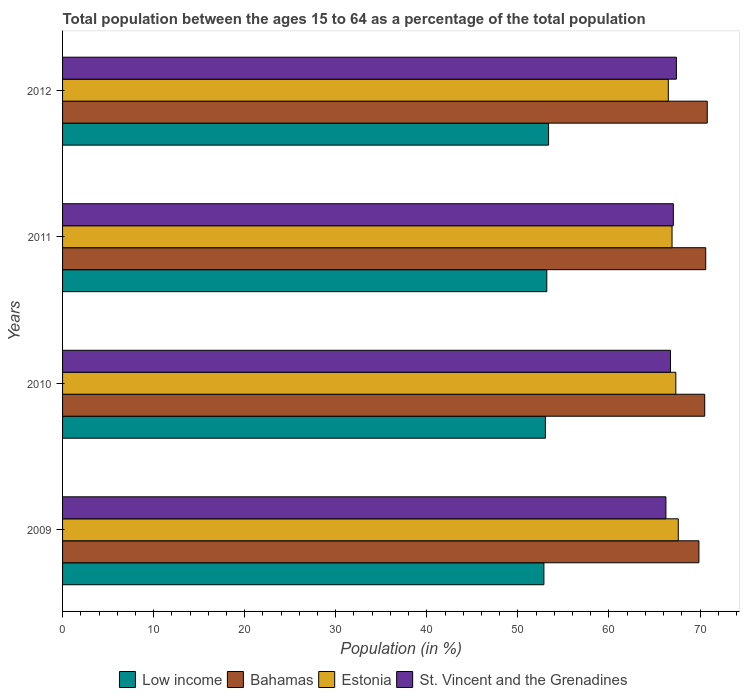How many different coloured bars are there?
Give a very brief answer. 4. How many groups of bars are there?
Your response must be concise. 4. Are the number of bars on each tick of the Y-axis equal?
Offer a very short reply. Yes. How many bars are there on the 4th tick from the top?
Provide a succinct answer. 4. How many bars are there on the 1st tick from the bottom?
Give a very brief answer. 4. What is the label of the 1st group of bars from the top?
Your answer should be very brief. 2012. What is the percentage of the population ages 15 to 64 in Bahamas in 2011?
Your response must be concise. 70.62. Across all years, what is the maximum percentage of the population ages 15 to 64 in Estonia?
Ensure brevity in your answer.  67.61. Across all years, what is the minimum percentage of the population ages 15 to 64 in Bahamas?
Offer a terse response. 69.88. What is the total percentage of the population ages 15 to 64 in Estonia in the graph?
Keep it short and to the point. 268.4. What is the difference between the percentage of the population ages 15 to 64 in Bahamas in 2010 and that in 2012?
Keep it short and to the point. -0.28. What is the difference between the percentage of the population ages 15 to 64 in Estonia in 2010 and the percentage of the population ages 15 to 64 in Low income in 2012?
Your answer should be very brief. 13.98. What is the average percentage of the population ages 15 to 64 in Bahamas per year?
Make the answer very short. 70.45. In the year 2011, what is the difference between the percentage of the population ages 15 to 64 in Estonia and percentage of the population ages 15 to 64 in Low income?
Ensure brevity in your answer.  13.75. What is the ratio of the percentage of the population ages 15 to 64 in Estonia in 2011 to that in 2012?
Offer a very short reply. 1.01. Is the percentage of the population ages 15 to 64 in Low income in 2010 less than that in 2011?
Keep it short and to the point. Yes. Is the difference between the percentage of the population ages 15 to 64 in Estonia in 2011 and 2012 greater than the difference between the percentage of the population ages 15 to 64 in Low income in 2011 and 2012?
Make the answer very short. Yes. What is the difference between the highest and the second highest percentage of the population ages 15 to 64 in St. Vincent and the Grenadines?
Your answer should be very brief. 0.34. What is the difference between the highest and the lowest percentage of the population ages 15 to 64 in Estonia?
Give a very brief answer. 1.1. In how many years, is the percentage of the population ages 15 to 64 in St. Vincent and the Grenadines greater than the average percentage of the population ages 15 to 64 in St. Vincent and the Grenadines taken over all years?
Offer a very short reply. 2. Is the sum of the percentage of the population ages 15 to 64 in Bahamas in 2011 and 2012 greater than the maximum percentage of the population ages 15 to 64 in St. Vincent and the Grenadines across all years?
Your response must be concise. Yes. Is it the case that in every year, the sum of the percentage of the population ages 15 to 64 in Bahamas and percentage of the population ages 15 to 64 in Estonia is greater than the sum of percentage of the population ages 15 to 64 in Low income and percentage of the population ages 15 to 64 in St. Vincent and the Grenadines?
Offer a terse response. Yes. What does the 1st bar from the top in 2010 represents?
Make the answer very short. St. Vincent and the Grenadines. What does the 2nd bar from the bottom in 2011 represents?
Provide a short and direct response. Bahamas. Is it the case that in every year, the sum of the percentage of the population ages 15 to 64 in St. Vincent and the Grenadines and percentage of the population ages 15 to 64 in Estonia is greater than the percentage of the population ages 15 to 64 in Low income?
Make the answer very short. Yes. Are all the bars in the graph horizontal?
Ensure brevity in your answer.  Yes. What is the title of the graph?
Your answer should be compact. Total population between the ages 15 to 64 as a percentage of the total population. What is the label or title of the X-axis?
Provide a succinct answer. Population (in %). What is the label or title of the Y-axis?
Make the answer very short. Years. What is the Population (in %) in Low income in 2009?
Keep it short and to the point. 52.86. What is the Population (in %) of Bahamas in 2009?
Give a very brief answer. 69.88. What is the Population (in %) in Estonia in 2009?
Your response must be concise. 67.61. What is the Population (in %) of St. Vincent and the Grenadines in 2009?
Provide a succinct answer. 66.25. What is the Population (in %) of Low income in 2010?
Your response must be concise. 53.02. What is the Population (in %) in Bahamas in 2010?
Give a very brief answer. 70.51. What is the Population (in %) of Estonia in 2010?
Ensure brevity in your answer.  67.34. What is the Population (in %) of St. Vincent and the Grenadines in 2010?
Keep it short and to the point. 66.76. What is the Population (in %) of Low income in 2011?
Ensure brevity in your answer.  53.17. What is the Population (in %) of Bahamas in 2011?
Your answer should be very brief. 70.62. What is the Population (in %) of Estonia in 2011?
Keep it short and to the point. 66.93. What is the Population (in %) of St. Vincent and the Grenadines in 2011?
Provide a succinct answer. 67.07. What is the Population (in %) of Low income in 2012?
Give a very brief answer. 53.37. What is the Population (in %) in Bahamas in 2012?
Make the answer very short. 70.79. What is the Population (in %) of Estonia in 2012?
Offer a very short reply. 66.52. What is the Population (in %) in St. Vincent and the Grenadines in 2012?
Offer a very short reply. 67.4. Across all years, what is the maximum Population (in %) of Low income?
Your answer should be compact. 53.37. Across all years, what is the maximum Population (in %) in Bahamas?
Keep it short and to the point. 70.79. Across all years, what is the maximum Population (in %) of Estonia?
Ensure brevity in your answer.  67.61. Across all years, what is the maximum Population (in %) of St. Vincent and the Grenadines?
Provide a short and direct response. 67.4. Across all years, what is the minimum Population (in %) in Low income?
Your answer should be compact. 52.86. Across all years, what is the minimum Population (in %) of Bahamas?
Provide a short and direct response. 69.88. Across all years, what is the minimum Population (in %) of Estonia?
Your answer should be very brief. 66.52. Across all years, what is the minimum Population (in %) in St. Vincent and the Grenadines?
Make the answer very short. 66.25. What is the total Population (in %) in Low income in the graph?
Offer a very short reply. 212.42. What is the total Population (in %) of Bahamas in the graph?
Keep it short and to the point. 281.81. What is the total Population (in %) of Estonia in the graph?
Offer a very short reply. 268.4. What is the total Population (in %) of St. Vincent and the Grenadines in the graph?
Offer a terse response. 267.48. What is the difference between the Population (in %) in Low income in 2009 and that in 2010?
Your response must be concise. -0.16. What is the difference between the Population (in %) of Bahamas in 2009 and that in 2010?
Make the answer very short. -0.64. What is the difference between the Population (in %) of Estonia in 2009 and that in 2010?
Give a very brief answer. 0.27. What is the difference between the Population (in %) in St. Vincent and the Grenadines in 2009 and that in 2010?
Provide a succinct answer. -0.5. What is the difference between the Population (in %) of Low income in 2009 and that in 2011?
Provide a succinct answer. -0.32. What is the difference between the Population (in %) of Bahamas in 2009 and that in 2011?
Keep it short and to the point. -0.75. What is the difference between the Population (in %) of Estonia in 2009 and that in 2011?
Your answer should be compact. 0.69. What is the difference between the Population (in %) in St. Vincent and the Grenadines in 2009 and that in 2011?
Make the answer very short. -0.81. What is the difference between the Population (in %) of Low income in 2009 and that in 2012?
Offer a terse response. -0.51. What is the difference between the Population (in %) in Bahamas in 2009 and that in 2012?
Your answer should be compact. -0.92. What is the difference between the Population (in %) in Estonia in 2009 and that in 2012?
Provide a succinct answer. 1.1. What is the difference between the Population (in %) in St. Vincent and the Grenadines in 2009 and that in 2012?
Your answer should be very brief. -1.15. What is the difference between the Population (in %) of Low income in 2010 and that in 2011?
Keep it short and to the point. -0.15. What is the difference between the Population (in %) of Bahamas in 2010 and that in 2011?
Make the answer very short. -0.11. What is the difference between the Population (in %) in Estonia in 2010 and that in 2011?
Your answer should be compact. 0.42. What is the difference between the Population (in %) of St. Vincent and the Grenadines in 2010 and that in 2011?
Your answer should be very brief. -0.31. What is the difference between the Population (in %) of Low income in 2010 and that in 2012?
Provide a short and direct response. -0.35. What is the difference between the Population (in %) of Bahamas in 2010 and that in 2012?
Offer a very short reply. -0.28. What is the difference between the Population (in %) in Estonia in 2010 and that in 2012?
Your answer should be compact. 0.83. What is the difference between the Population (in %) in St. Vincent and the Grenadines in 2010 and that in 2012?
Provide a short and direct response. -0.65. What is the difference between the Population (in %) in Low income in 2011 and that in 2012?
Offer a very short reply. -0.2. What is the difference between the Population (in %) in Bahamas in 2011 and that in 2012?
Provide a succinct answer. -0.17. What is the difference between the Population (in %) in Estonia in 2011 and that in 2012?
Ensure brevity in your answer.  0.41. What is the difference between the Population (in %) in St. Vincent and the Grenadines in 2011 and that in 2012?
Your answer should be compact. -0.34. What is the difference between the Population (in %) of Low income in 2009 and the Population (in %) of Bahamas in 2010?
Offer a terse response. -17.66. What is the difference between the Population (in %) of Low income in 2009 and the Population (in %) of Estonia in 2010?
Offer a terse response. -14.49. What is the difference between the Population (in %) in Low income in 2009 and the Population (in %) in St. Vincent and the Grenadines in 2010?
Offer a terse response. -13.9. What is the difference between the Population (in %) in Bahamas in 2009 and the Population (in %) in Estonia in 2010?
Your answer should be compact. 2.54. What is the difference between the Population (in %) of Bahamas in 2009 and the Population (in %) of St. Vincent and the Grenadines in 2010?
Ensure brevity in your answer.  3.12. What is the difference between the Population (in %) in Estonia in 2009 and the Population (in %) in St. Vincent and the Grenadines in 2010?
Make the answer very short. 0.86. What is the difference between the Population (in %) in Low income in 2009 and the Population (in %) in Bahamas in 2011?
Offer a very short reply. -17.77. What is the difference between the Population (in %) in Low income in 2009 and the Population (in %) in Estonia in 2011?
Your response must be concise. -14.07. What is the difference between the Population (in %) of Low income in 2009 and the Population (in %) of St. Vincent and the Grenadines in 2011?
Provide a succinct answer. -14.21. What is the difference between the Population (in %) of Bahamas in 2009 and the Population (in %) of Estonia in 2011?
Give a very brief answer. 2.95. What is the difference between the Population (in %) in Bahamas in 2009 and the Population (in %) in St. Vincent and the Grenadines in 2011?
Your response must be concise. 2.81. What is the difference between the Population (in %) of Estonia in 2009 and the Population (in %) of St. Vincent and the Grenadines in 2011?
Ensure brevity in your answer.  0.55. What is the difference between the Population (in %) of Low income in 2009 and the Population (in %) of Bahamas in 2012?
Provide a short and direct response. -17.94. What is the difference between the Population (in %) of Low income in 2009 and the Population (in %) of Estonia in 2012?
Give a very brief answer. -13.66. What is the difference between the Population (in %) of Low income in 2009 and the Population (in %) of St. Vincent and the Grenadines in 2012?
Keep it short and to the point. -14.55. What is the difference between the Population (in %) in Bahamas in 2009 and the Population (in %) in Estonia in 2012?
Your response must be concise. 3.36. What is the difference between the Population (in %) of Bahamas in 2009 and the Population (in %) of St. Vincent and the Grenadines in 2012?
Keep it short and to the point. 2.47. What is the difference between the Population (in %) of Estonia in 2009 and the Population (in %) of St. Vincent and the Grenadines in 2012?
Offer a terse response. 0.21. What is the difference between the Population (in %) of Low income in 2010 and the Population (in %) of Bahamas in 2011?
Offer a very short reply. -17.61. What is the difference between the Population (in %) in Low income in 2010 and the Population (in %) in Estonia in 2011?
Your response must be concise. -13.91. What is the difference between the Population (in %) in Low income in 2010 and the Population (in %) in St. Vincent and the Grenadines in 2011?
Offer a very short reply. -14.05. What is the difference between the Population (in %) of Bahamas in 2010 and the Population (in %) of Estonia in 2011?
Your answer should be very brief. 3.59. What is the difference between the Population (in %) of Bahamas in 2010 and the Population (in %) of St. Vincent and the Grenadines in 2011?
Make the answer very short. 3.45. What is the difference between the Population (in %) in Estonia in 2010 and the Population (in %) in St. Vincent and the Grenadines in 2011?
Offer a terse response. 0.28. What is the difference between the Population (in %) in Low income in 2010 and the Population (in %) in Bahamas in 2012?
Make the answer very short. -17.77. What is the difference between the Population (in %) in Low income in 2010 and the Population (in %) in Estonia in 2012?
Provide a short and direct response. -13.5. What is the difference between the Population (in %) of Low income in 2010 and the Population (in %) of St. Vincent and the Grenadines in 2012?
Give a very brief answer. -14.38. What is the difference between the Population (in %) of Bahamas in 2010 and the Population (in %) of Estonia in 2012?
Provide a short and direct response. 4. What is the difference between the Population (in %) of Bahamas in 2010 and the Population (in %) of St. Vincent and the Grenadines in 2012?
Make the answer very short. 3.11. What is the difference between the Population (in %) in Estonia in 2010 and the Population (in %) in St. Vincent and the Grenadines in 2012?
Make the answer very short. -0.06. What is the difference between the Population (in %) in Low income in 2011 and the Population (in %) in Bahamas in 2012?
Keep it short and to the point. -17.62. What is the difference between the Population (in %) in Low income in 2011 and the Population (in %) in Estonia in 2012?
Your response must be concise. -13.34. What is the difference between the Population (in %) in Low income in 2011 and the Population (in %) in St. Vincent and the Grenadines in 2012?
Keep it short and to the point. -14.23. What is the difference between the Population (in %) of Bahamas in 2011 and the Population (in %) of Estonia in 2012?
Your answer should be very brief. 4.11. What is the difference between the Population (in %) in Bahamas in 2011 and the Population (in %) in St. Vincent and the Grenadines in 2012?
Keep it short and to the point. 3.22. What is the difference between the Population (in %) in Estonia in 2011 and the Population (in %) in St. Vincent and the Grenadines in 2012?
Provide a short and direct response. -0.48. What is the average Population (in %) of Low income per year?
Give a very brief answer. 53.1. What is the average Population (in %) of Bahamas per year?
Ensure brevity in your answer.  70.45. What is the average Population (in %) of Estonia per year?
Offer a very short reply. 67.1. What is the average Population (in %) in St. Vincent and the Grenadines per year?
Offer a very short reply. 66.87. In the year 2009, what is the difference between the Population (in %) of Low income and Population (in %) of Bahamas?
Keep it short and to the point. -17.02. In the year 2009, what is the difference between the Population (in %) of Low income and Population (in %) of Estonia?
Provide a succinct answer. -14.76. In the year 2009, what is the difference between the Population (in %) of Low income and Population (in %) of St. Vincent and the Grenadines?
Provide a succinct answer. -13.4. In the year 2009, what is the difference between the Population (in %) of Bahamas and Population (in %) of Estonia?
Keep it short and to the point. 2.27. In the year 2009, what is the difference between the Population (in %) of Bahamas and Population (in %) of St. Vincent and the Grenadines?
Ensure brevity in your answer.  3.63. In the year 2009, what is the difference between the Population (in %) in Estonia and Population (in %) in St. Vincent and the Grenadines?
Make the answer very short. 1.36. In the year 2010, what is the difference between the Population (in %) of Low income and Population (in %) of Bahamas?
Provide a short and direct response. -17.5. In the year 2010, what is the difference between the Population (in %) of Low income and Population (in %) of Estonia?
Give a very brief answer. -14.32. In the year 2010, what is the difference between the Population (in %) in Low income and Population (in %) in St. Vincent and the Grenadines?
Ensure brevity in your answer.  -13.74. In the year 2010, what is the difference between the Population (in %) in Bahamas and Population (in %) in Estonia?
Your response must be concise. 3.17. In the year 2010, what is the difference between the Population (in %) of Bahamas and Population (in %) of St. Vincent and the Grenadines?
Your response must be concise. 3.76. In the year 2010, what is the difference between the Population (in %) of Estonia and Population (in %) of St. Vincent and the Grenadines?
Give a very brief answer. 0.59. In the year 2011, what is the difference between the Population (in %) of Low income and Population (in %) of Bahamas?
Make the answer very short. -17.45. In the year 2011, what is the difference between the Population (in %) of Low income and Population (in %) of Estonia?
Your response must be concise. -13.75. In the year 2011, what is the difference between the Population (in %) in Low income and Population (in %) in St. Vincent and the Grenadines?
Provide a short and direct response. -13.89. In the year 2011, what is the difference between the Population (in %) in Bahamas and Population (in %) in Estonia?
Offer a terse response. 3.7. In the year 2011, what is the difference between the Population (in %) in Bahamas and Population (in %) in St. Vincent and the Grenadines?
Your response must be concise. 3.56. In the year 2011, what is the difference between the Population (in %) in Estonia and Population (in %) in St. Vincent and the Grenadines?
Provide a short and direct response. -0.14. In the year 2012, what is the difference between the Population (in %) of Low income and Population (in %) of Bahamas?
Make the answer very short. -17.43. In the year 2012, what is the difference between the Population (in %) of Low income and Population (in %) of Estonia?
Offer a very short reply. -13.15. In the year 2012, what is the difference between the Population (in %) of Low income and Population (in %) of St. Vincent and the Grenadines?
Your response must be concise. -14.04. In the year 2012, what is the difference between the Population (in %) in Bahamas and Population (in %) in Estonia?
Offer a terse response. 4.28. In the year 2012, what is the difference between the Population (in %) in Bahamas and Population (in %) in St. Vincent and the Grenadines?
Your response must be concise. 3.39. In the year 2012, what is the difference between the Population (in %) of Estonia and Population (in %) of St. Vincent and the Grenadines?
Keep it short and to the point. -0.89. What is the ratio of the Population (in %) in St. Vincent and the Grenadines in 2009 to that in 2010?
Your answer should be very brief. 0.99. What is the ratio of the Population (in %) in Estonia in 2009 to that in 2011?
Keep it short and to the point. 1.01. What is the ratio of the Population (in %) in Low income in 2009 to that in 2012?
Your answer should be compact. 0.99. What is the ratio of the Population (in %) of Bahamas in 2009 to that in 2012?
Provide a short and direct response. 0.99. What is the ratio of the Population (in %) of Estonia in 2009 to that in 2012?
Ensure brevity in your answer.  1.02. What is the ratio of the Population (in %) of St. Vincent and the Grenadines in 2009 to that in 2012?
Your response must be concise. 0.98. What is the ratio of the Population (in %) of Low income in 2010 to that in 2011?
Provide a succinct answer. 1. What is the ratio of the Population (in %) of Estonia in 2010 to that in 2011?
Offer a terse response. 1.01. What is the ratio of the Population (in %) of St. Vincent and the Grenadines in 2010 to that in 2011?
Offer a very short reply. 1. What is the ratio of the Population (in %) of Low income in 2010 to that in 2012?
Offer a very short reply. 0.99. What is the ratio of the Population (in %) of Estonia in 2010 to that in 2012?
Make the answer very short. 1.01. What is the ratio of the Population (in %) of Estonia in 2011 to that in 2012?
Keep it short and to the point. 1.01. What is the difference between the highest and the second highest Population (in %) of Low income?
Ensure brevity in your answer.  0.2. What is the difference between the highest and the second highest Population (in %) in Bahamas?
Keep it short and to the point. 0.17. What is the difference between the highest and the second highest Population (in %) in Estonia?
Keep it short and to the point. 0.27. What is the difference between the highest and the second highest Population (in %) in St. Vincent and the Grenadines?
Your answer should be compact. 0.34. What is the difference between the highest and the lowest Population (in %) in Low income?
Provide a succinct answer. 0.51. What is the difference between the highest and the lowest Population (in %) in Bahamas?
Ensure brevity in your answer.  0.92. What is the difference between the highest and the lowest Population (in %) in Estonia?
Keep it short and to the point. 1.1. What is the difference between the highest and the lowest Population (in %) in St. Vincent and the Grenadines?
Keep it short and to the point. 1.15. 